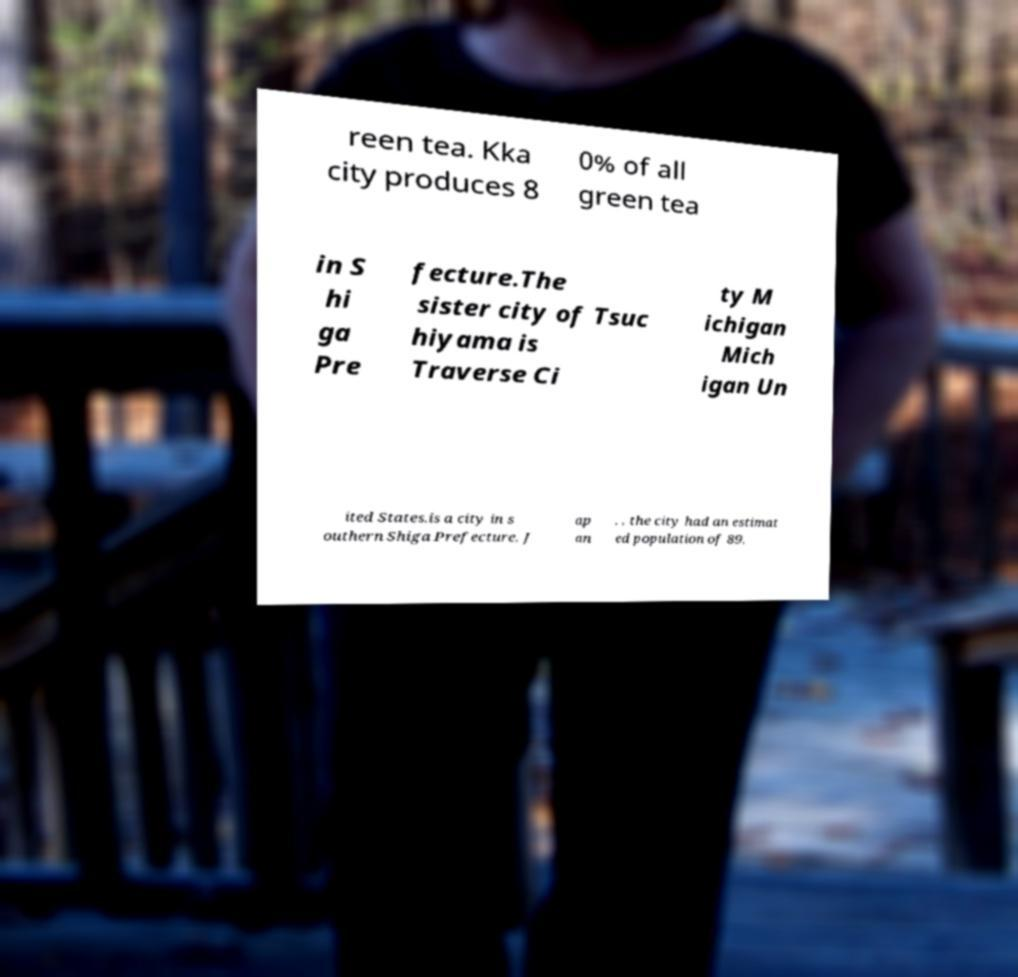I need the written content from this picture converted into text. Can you do that? reen tea. Kka city produces 8 0% of all green tea in S hi ga Pre fecture.The sister city of Tsuc hiyama is Traverse Ci ty M ichigan Mich igan Un ited States.is a city in s outhern Shiga Prefecture, J ap an . , the city had an estimat ed population of 89, 